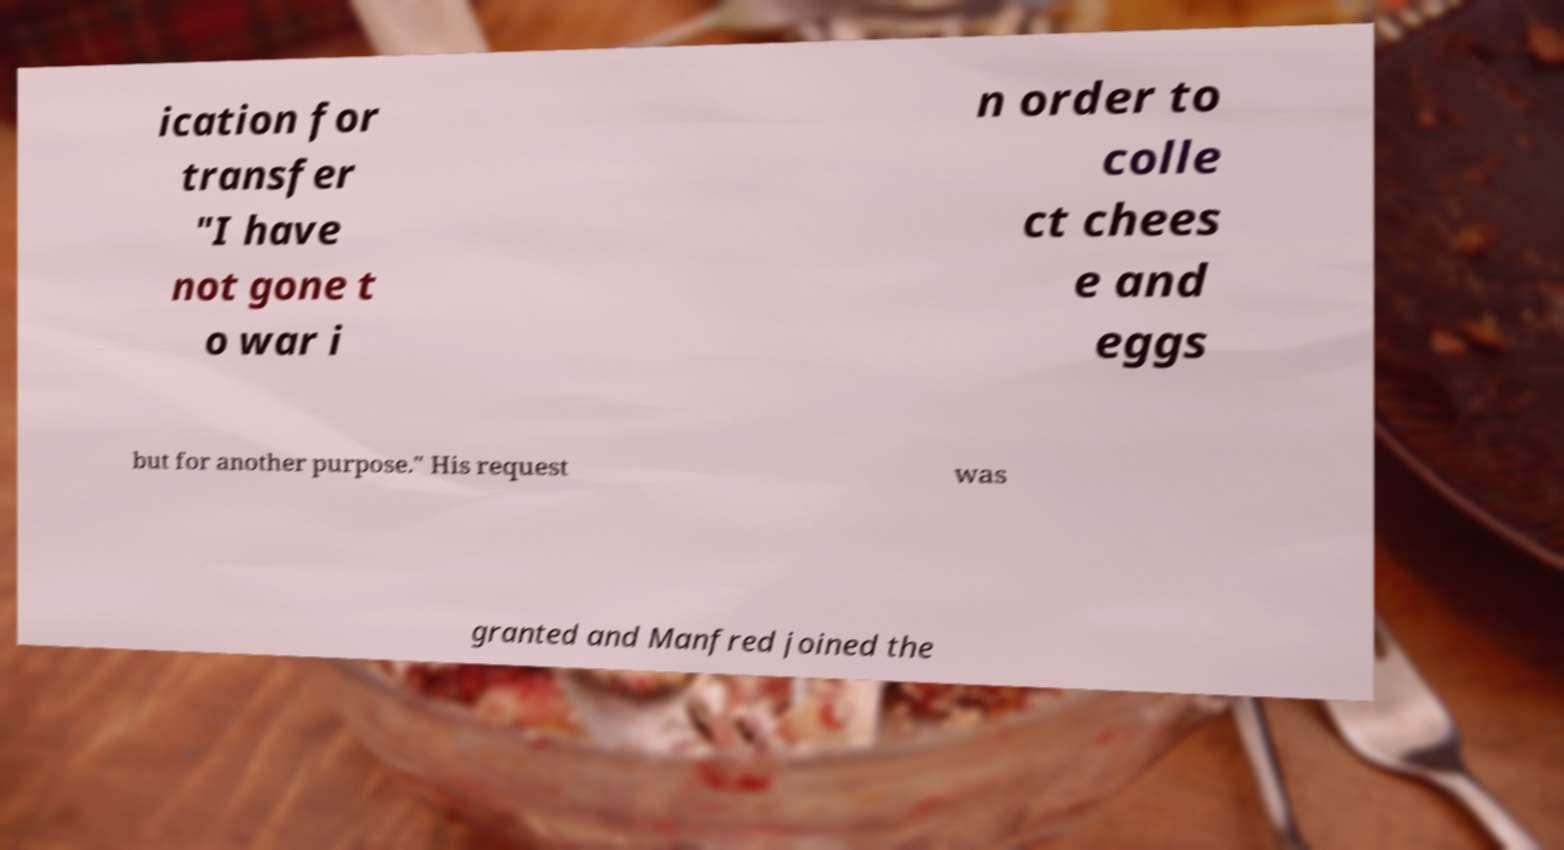Please identify and transcribe the text found in this image. ication for transfer "I have not gone t o war i n order to colle ct chees e and eggs but for another purpose." His request was granted and Manfred joined the 